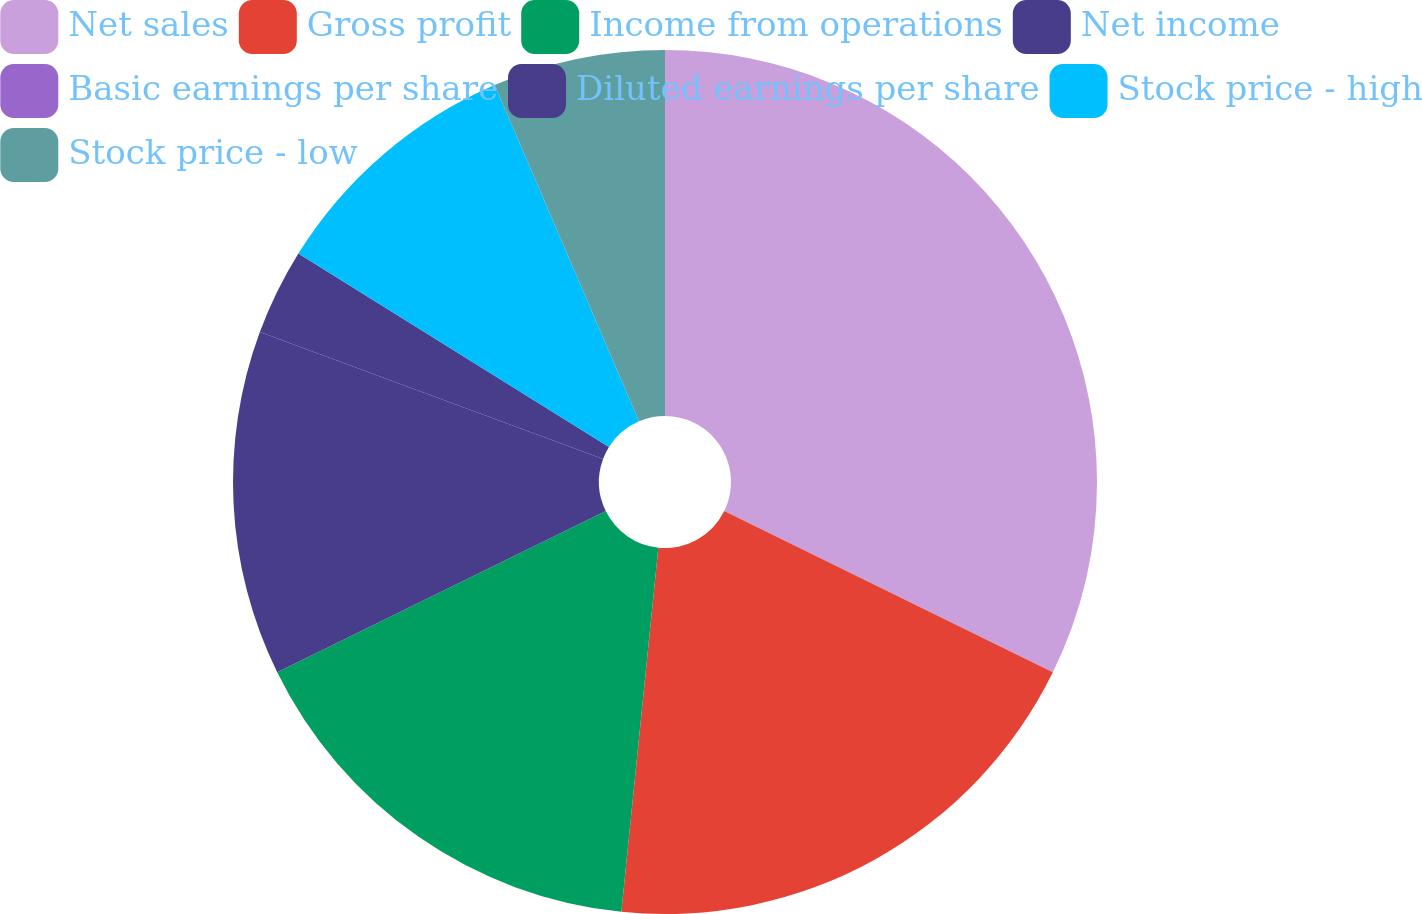<chart> <loc_0><loc_0><loc_500><loc_500><pie_chart><fcel>Net sales<fcel>Gross profit<fcel>Income from operations<fcel>Net income<fcel>Basic earnings per share<fcel>Diluted earnings per share<fcel>Stock price - high<fcel>Stock price - low<nl><fcel>32.26%<fcel>19.35%<fcel>16.13%<fcel>12.9%<fcel>0.0%<fcel>3.23%<fcel>9.68%<fcel>6.45%<nl></chart> 